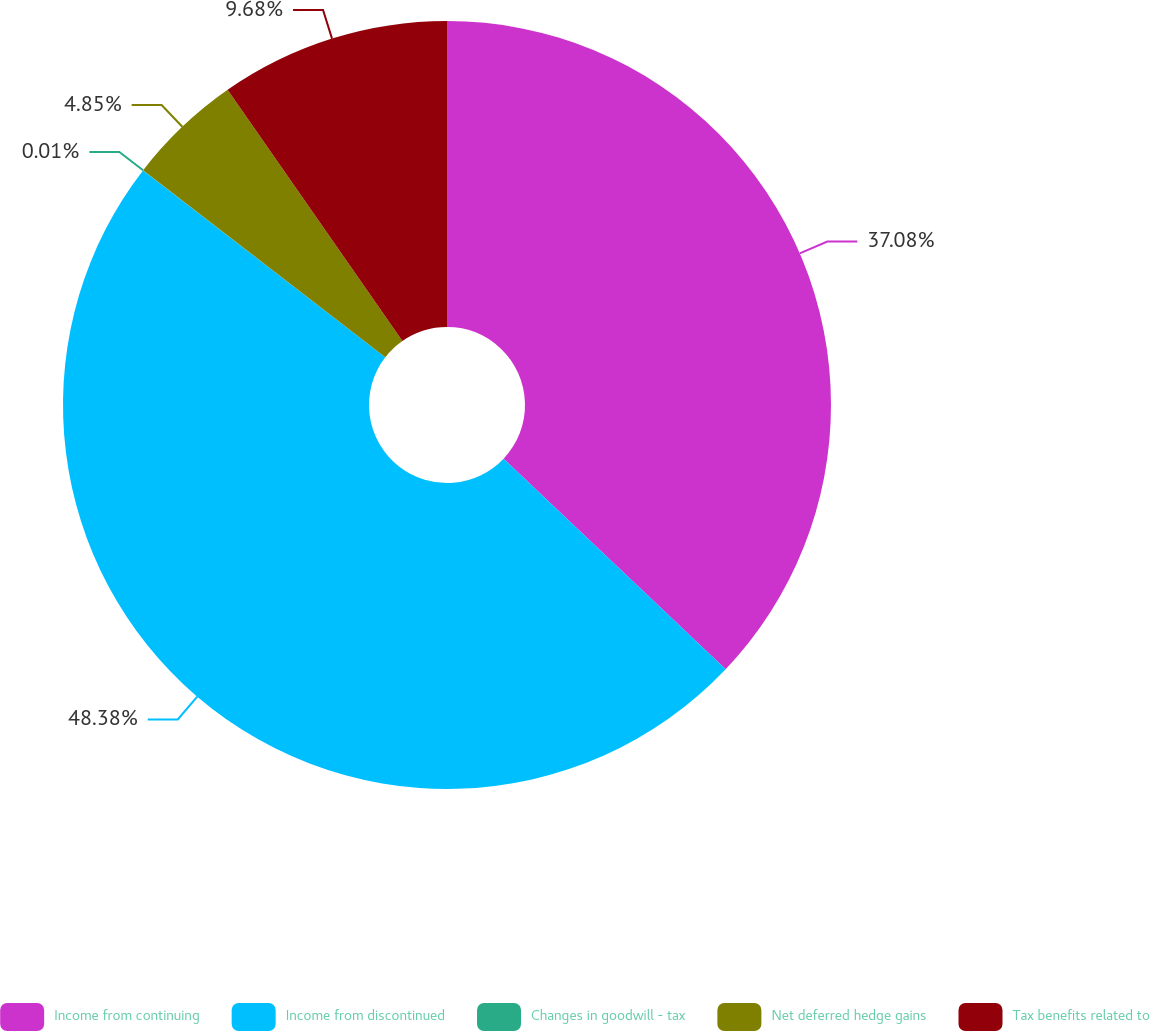Convert chart. <chart><loc_0><loc_0><loc_500><loc_500><pie_chart><fcel>Income from continuing<fcel>Income from discontinued<fcel>Changes in goodwill - tax<fcel>Net deferred hedge gains<fcel>Tax benefits related to<nl><fcel>37.08%<fcel>48.39%<fcel>0.01%<fcel>4.85%<fcel>9.68%<nl></chart> 